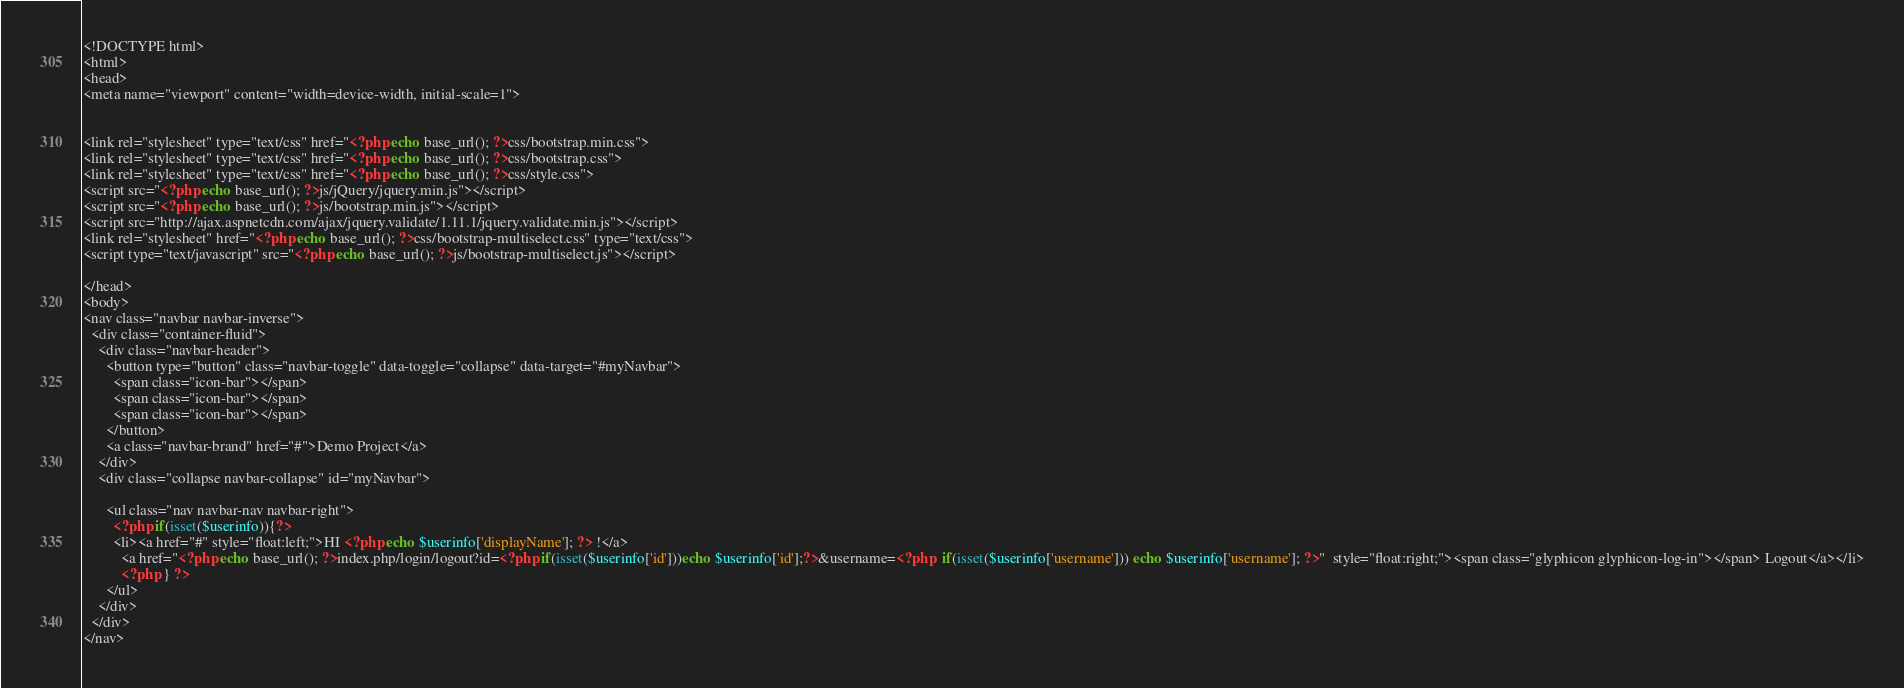Convert code to text. <code><loc_0><loc_0><loc_500><loc_500><_PHP_><!DOCTYPE html>
<html>
<head>
<meta name="viewport" content="width=device-width, initial-scale=1">


<link rel="stylesheet" type="text/css" href="<?php echo base_url(); ?>css/bootstrap.min.css">
<link rel="stylesheet" type="text/css" href="<?php echo base_url(); ?>css/bootstrap.css">
<link rel="stylesheet" type="text/css" href="<?php echo base_url(); ?>css/style.css">
<script src="<?php echo base_url(); ?>js/jQuery/jquery.min.js"></script>
<script src="<?php echo base_url(); ?>js/bootstrap.min.js"></script>
<script src="http://ajax.aspnetcdn.com/ajax/jquery.validate/1.11.1/jquery.validate.min.js"></script>
<link rel="stylesheet" href="<?php echo base_url(); ?>css/bootstrap-multiselect.css" type="text/css">
<script type="text/javascript" src="<?php echo base_url(); ?>js/bootstrap-multiselect.js"></script>

</head>
<body>
<nav class="navbar navbar-inverse">
  <div class="container-fluid">
    <div class="navbar-header">
      <button type="button" class="navbar-toggle" data-toggle="collapse" data-target="#myNavbar">
        <span class="icon-bar"></span>
        <span class="icon-bar"></span>
        <span class="icon-bar"></span>                        
      </button>
      <a class="navbar-brand" href="#">Demo Project</a>
    </div>
    <div class="collapse navbar-collapse" id="myNavbar">
      
      <ul class="nav navbar-nav navbar-right">
        <?php if(isset($userinfo)){?>
        <li><a href="#" style="float:left;">HI <?php echo $userinfo['displayName']; ?> !</a>
          <a href="<?php echo base_url(); ?>index.php/login/logout?id=<?php if(isset($userinfo['id']))echo $userinfo['id'];?>&username=<?php  if(isset($userinfo['username'])) echo $userinfo['username']; ?>"  style="float:right;"><span class="glyphicon glyphicon-log-in"></span> Logout</a></li>
          <?php } ?>
      </ul>
    </div>
  </div>
</nav></code> 